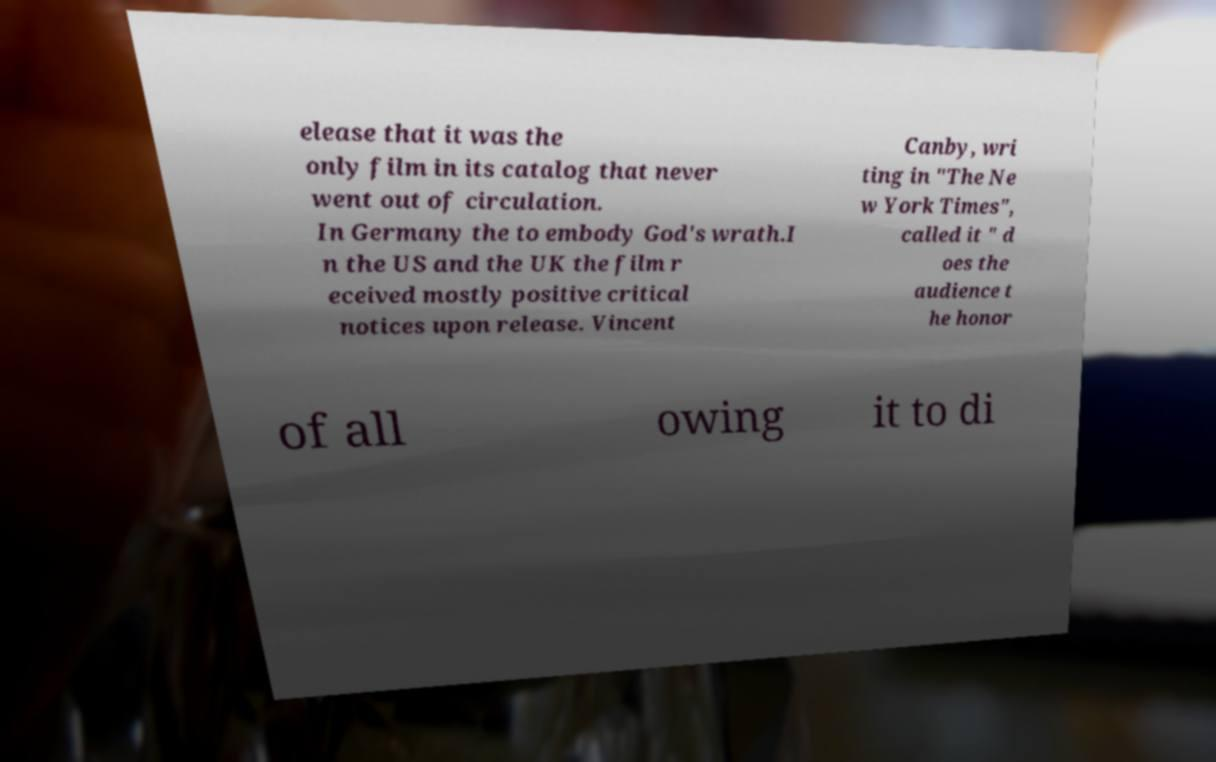I need the written content from this picture converted into text. Can you do that? elease that it was the only film in its catalog that never went out of circulation. In Germany the to embody God's wrath.I n the US and the UK the film r eceived mostly positive critical notices upon release. Vincent Canby, wri ting in "The Ne w York Times", called it " d oes the audience t he honor of all owing it to di 